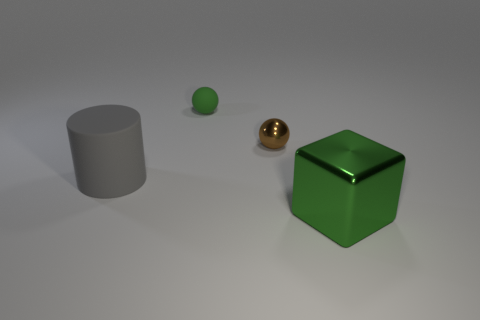What is the color of the cube?
Offer a very short reply. Green. Are there any blocks that have the same color as the small rubber thing?
Your response must be concise. Yes. Do the shiny cube and the rubber object behind the cylinder have the same color?
Provide a short and direct response. Yes. There is a big object that is on the left side of the small object that is in front of the tiny green sphere; what color is it?
Provide a short and direct response. Gray. There is a ball in front of the green object that is behind the large gray matte object; are there any large shiny cubes that are left of it?
Offer a very short reply. No. What color is the big object that is the same material as the tiny brown object?
Your answer should be compact. Green. How many small green objects are the same material as the large gray thing?
Your answer should be compact. 1. Does the tiny brown thing have the same material as the thing that is in front of the large cylinder?
Give a very brief answer. Yes. How many things are large things to the right of the rubber cylinder or big metallic cubes?
Offer a very short reply. 1. How big is the green object in front of the big object that is behind the large object that is right of the big gray thing?
Keep it short and to the point. Large. 